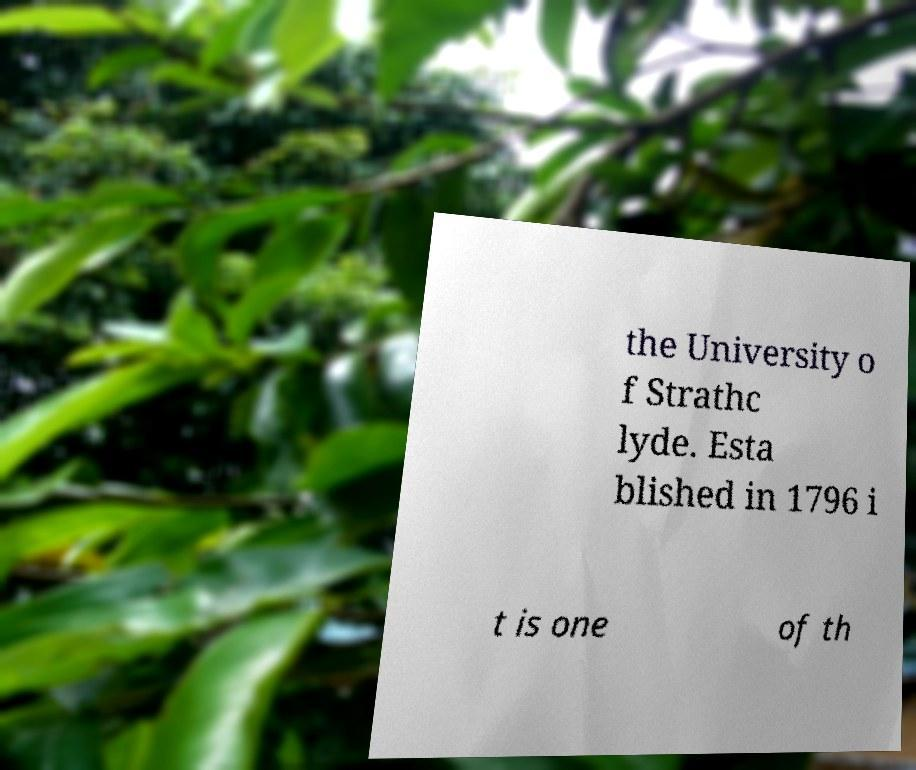Could you assist in decoding the text presented in this image and type it out clearly? the University o f Strathc lyde. Esta blished in 1796 i t is one of th 